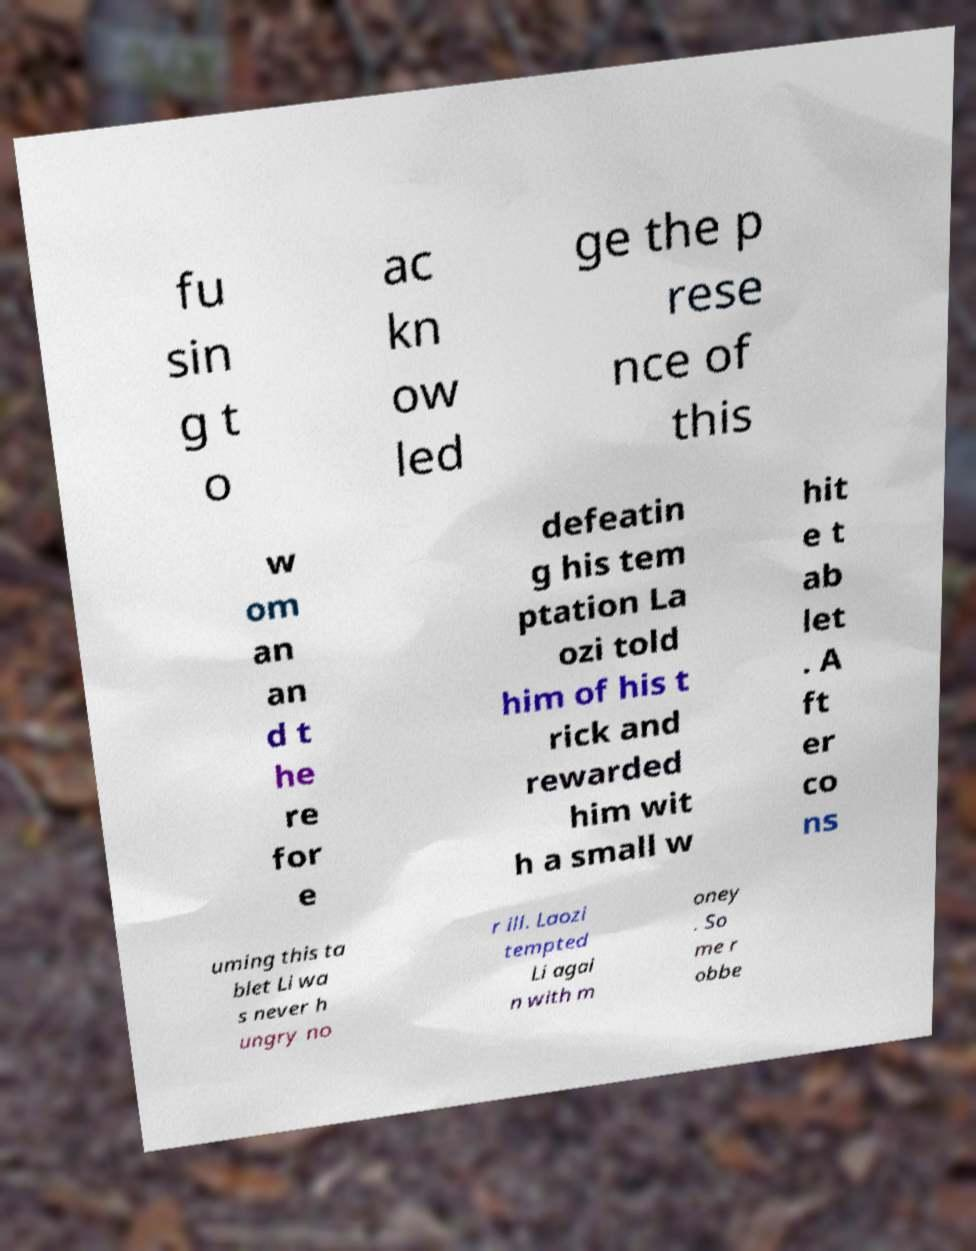Can you read and provide the text displayed in the image?This photo seems to have some interesting text. Can you extract and type it out for me? fu sin g t o ac kn ow led ge the p rese nce of this w om an an d t he re for e defeatin g his tem ptation La ozi told him of his t rick and rewarded him wit h a small w hit e t ab let . A ft er co ns uming this ta blet Li wa s never h ungry no r ill. Laozi tempted Li agai n with m oney . So me r obbe 